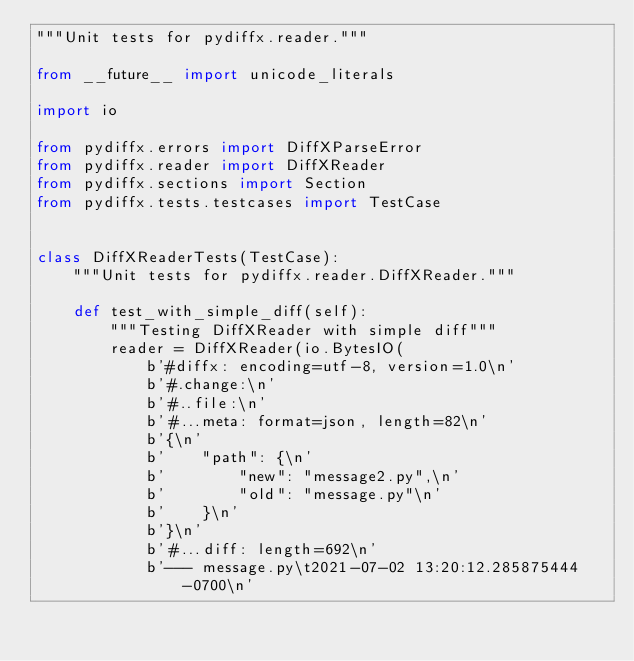<code> <loc_0><loc_0><loc_500><loc_500><_Python_>"""Unit tests for pydiffx.reader."""

from __future__ import unicode_literals

import io

from pydiffx.errors import DiffXParseError
from pydiffx.reader import DiffXReader
from pydiffx.sections import Section
from pydiffx.tests.testcases import TestCase


class DiffXReaderTests(TestCase):
    """Unit tests for pydiffx.reader.DiffXReader."""

    def test_with_simple_diff(self):
        """Testing DiffXReader with simple diff"""
        reader = DiffXReader(io.BytesIO(
            b'#diffx: encoding=utf-8, version=1.0\n'
            b'#.change:\n'
            b'#..file:\n'
            b'#...meta: format=json, length=82\n'
            b'{\n'
            b'    "path": {\n'
            b'        "new": "message2.py",\n'
            b'        "old": "message.py"\n'
            b'    }\n'
            b'}\n'
            b'#...diff: length=692\n'
            b'--- message.py\t2021-07-02 13:20:12.285875444 -0700\n'</code> 